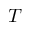Convert formula to latex. <formula><loc_0><loc_0><loc_500><loc_500>T</formula> 